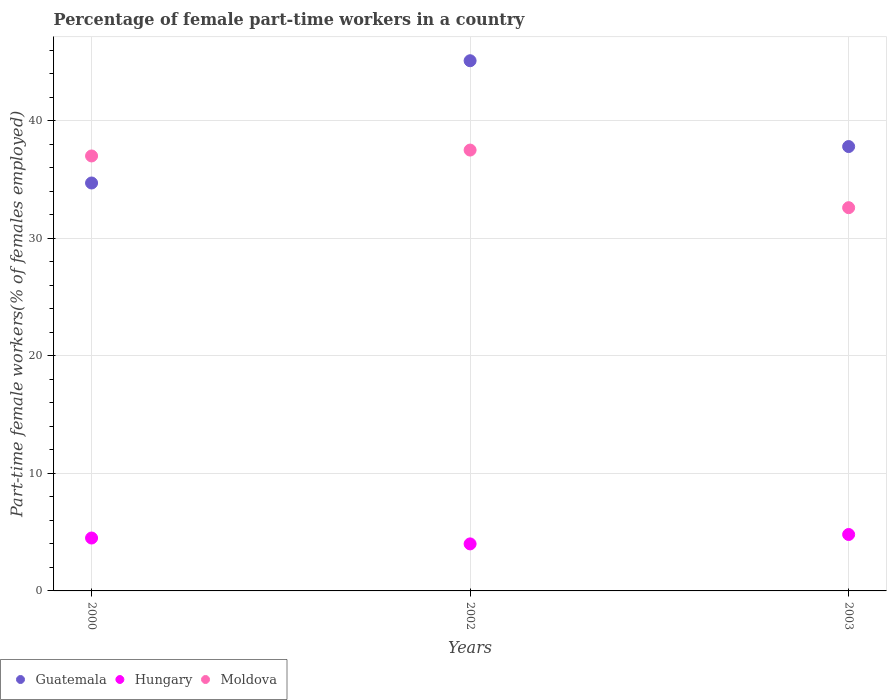Is the number of dotlines equal to the number of legend labels?
Provide a succinct answer. Yes. What is the percentage of female part-time workers in Moldova in 2003?
Provide a short and direct response. 32.6. Across all years, what is the maximum percentage of female part-time workers in Moldova?
Your answer should be very brief. 37.5. Across all years, what is the minimum percentage of female part-time workers in Moldova?
Give a very brief answer. 32.6. In which year was the percentage of female part-time workers in Hungary maximum?
Provide a succinct answer. 2003. In which year was the percentage of female part-time workers in Moldova minimum?
Make the answer very short. 2003. What is the total percentage of female part-time workers in Hungary in the graph?
Give a very brief answer. 13.3. What is the difference between the percentage of female part-time workers in Guatemala in 2002 and that in 2003?
Keep it short and to the point. 7.3. What is the difference between the percentage of female part-time workers in Moldova in 2003 and the percentage of female part-time workers in Hungary in 2000?
Ensure brevity in your answer.  28.1. What is the average percentage of female part-time workers in Guatemala per year?
Offer a terse response. 39.2. In the year 2000, what is the difference between the percentage of female part-time workers in Guatemala and percentage of female part-time workers in Hungary?
Keep it short and to the point. 30.2. In how many years, is the percentage of female part-time workers in Moldova greater than 26 %?
Make the answer very short. 3. What is the ratio of the percentage of female part-time workers in Guatemala in 2002 to that in 2003?
Provide a short and direct response. 1.19. Is the difference between the percentage of female part-time workers in Guatemala in 2000 and 2003 greater than the difference between the percentage of female part-time workers in Hungary in 2000 and 2003?
Your response must be concise. No. What is the difference between the highest and the lowest percentage of female part-time workers in Moldova?
Offer a terse response. 4.9. Is the sum of the percentage of female part-time workers in Guatemala in 2000 and 2002 greater than the maximum percentage of female part-time workers in Moldova across all years?
Keep it short and to the point. Yes. Is the percentage of female part-time workers in Moldova strictly less than the percentage of female part-time workers in Hungary over the years?
Provide a short and direct response. No. What is the difference between two consecutive major ticks on the Y-axis?
Your answer should be very brief. 10. Where does the legend appear in the graph?
Provide a short and direct response. Bottom left. How many legend labels are there?
Your answer should be compact. 3. What is the title of the graph?
Make the answer very short. Percentage of female part-time workers in a country. Does "Bhutan" appear as one of the legend labels in the graph?
Provide a short and direct response. No. What is the label or title of the X-axis?
Keep it short and to the point. Years. What is the label or title of the Y-axis?
Provide a succinct answer. Part-time female workers(% of females employed). What is the Part-time female workers(% of females employed) in Guatemala in 2000?
Give a very brief answer. 34.7. What is the Part-time female workers(% of females employed) of Moldova in 2000?
Provide a succinct answer. 37. What is the Part-time female workers(% of females employed) of Guatemala in 2002?
Make the answer very short. 45.1. What is the Part-time female workers(% of females employed) in Moldova in 2002?
Your answer should be very brief. 37.5. What is the Part-time female workers(% of females employed) in Guatemala in 2003?
Keep it short and to the point. 37.8. What is the Part-time female workers(% of females employed) in Hungary in 2003?
Make the answer very short. 4.8. What is the Part-time female workers(% of females employed) in Moldova in 2003?
Keep it short and to the point. 32.6. Across all years, what is the maximum Part-time female workers(% of females employed) of Guatemala?
Your answer should be very brief. 45.1. Across all years, what is the maximum Part-time female workers(% of females employed) of Hungary?
Ensure brevity in your answer.  4.8. Across all years, what is the maximum Part-time female workers(% of females employed) in Moldova?
Your response must be concise. 37.5. Across all years, what is the minimum Part-time female workers(% of females employed) in Guatemala?
Give a very brief answer. 34.7. Across all years, what is the minimum Part-time female workers(% of females employed) in Moldova?
Your answer should be very brief. 32.6. What is the total Part-time female workers(% of females employed) in Guatemala in the graph?
Give a very brief answer. 117.6. What is the total Part-time female workers(% of females employed) of Moldova in the graph?
Provide a short and direct response. 107.1. What is the difference between the Part-time female workers(% of females employed) of Moldova in 2000 and that in 2002?
Make the answer very short. -0.5. What is the difference between the Part-time female workers(% of females employed) of Guatemala in 2000 and that in 2003?
Your answer should be compact. -3.1. What is the difference between the Part-time female workers(% of females employed) in Moldova in 2000 and that in 2003?
Your answer should be compact. 4.4. What is the difference between the Part-time female workers(% of females employed) of Guatemala in 2002 and that in 2003?
Provide a succinct answer. 7.3. What is the difference between the Part-time female workers(% of females employed) in Hungary in 2002 and that in 2003?
Give a very brief answer. -0.8. What is the difference between the Part-time female workers(% of females employed) of Moldova in 2002 and that in 2003?
Keep it short and to the point. 4.9. What is the difference between the Part-time female workers(% of females employed) of Guatemala in 2000 and the Part-time female workers(% of females employed) of Hungary in 2002?
Offer a very short reply. 30.7. What is the difference between the Part-time female workers(% of females employed) in Hungary in 2000 and the Part-time female workers(% of females employed) in Moldova in 2002?
Offer a very short reply. -33. What is the difference between the Part-time female workers(% of females employed) of Guatemala in 2000 and the Part-time female workers(% of females employed) of Hungary in 2003?
Make the answer very short. 29.9. What is the difference between the Part-time female workers(% of females employed) of Guatemala in 2000 and the Part-time female workers(% of females employed) of Moldova in 2003?
Your answer should be very brief. 2.1. What is the difference between the Part-time female workers(% of females employed) of Hungary in 2000 and the Part-time female workers(% of females employed) of Moldova in 2003?
Offer a terse response. -28.1. What is the difference between the Part-time female workers(% of females employed) in Guatemala in 2002 and the Part-time female workers(% of females employed) in Hungary in 2003?
Offer a very short reply. 40.3. What is the difference between the Part-time female workers(% of females employed) of Guatemala in 2002 and the Part-time female workers(% of females employed) of Moldova in 2003?
Make the answer very short. 12.5. What is the difference between the Part-time female workers(% of females employed) of Hungary in 2002 and the Part-time female workers(% of females employed) of Moldova in 2003?
Give a very brief answer. -28.6. What is the average Part-time female workers(% of females employed) of Guatemala per year?
Give a very brief answer. 39.2. What is the average Part-time female workers(% of females employed) in Hungary per year?
Make the answer very short. 4.43. What is the average Part-time female workers(% of females employed) of Moldova per year?
Offer a very short reply. 35.7. In the year 2000, what is the difference between the Part-time female workers(% of females employed) of Guatemala and Part-time female workers(% of females employed) of Hungary?
Ensure brevity in your answer.  30.2. In the year 2000, what is the difference between the Part-time female workers(% of females employed) of Hungary and Part-time female workers(% of females employed) of Moldova?
Provide a succinct answer. -32.5. In the year 2002, what is the difference between the Part-time female workers(% of females employed) in Guatemala and Part-time female workers(% of females employed) in Hungary?
Your response must be concise. 41.1. In the year 2002, what is the difference between the Part-time female workers(% of females employed) in Hungary and Part-time female workers(% of females employed) in Moldova?
Provide a succinct answer. -33.5. In the year 2003, what is the difference between the Part-time female workers(% of females employed) of Guatemala and Part-time female workers(% of females employed) of Hungary?
Your response must be concise. 33. In the year 2003, what is the difference between the Part-time female workers(% of females employed) of Guatemala and Part-time female workers(% of females employed) of Moldova?
Give a very brief answer. 5.2. In the year 2003, what is the difference between the Part-time female workers(% of females employed) in Hungary and Part-time female workers(% of females employed) in Moldova?
Provide a short and direct response. -27.8. What is the ratio of the Part-time female workers(% of females employed) in Guatemala in 2000 to that in 2002?
Your answer should be compact. 0.77. What is the ratio of the Part-time female workers(% of females employed) in Hungary in 2000 to that in 2002?
Your response must be concise. 1.12. What is the ratio of the Part-time female workers(% of females employed) in Moldova in 2000 to that in 2002?
Your response must be concise. 0.99. What is the ratio of the Part-time female workers(% of females employed) in Guatemala in 2000 to that in 2003?
Keep it short and to the point. 0.92. What is the ratio of the Part-time female workers(% of females employed) of Moldova in 2000 to that in 2003?
Your answer should be very brief. 1.14. What is the ratio of the Part-time female workers(% of females employed) in Guatemala in 2002 to that in 2003?
Offer a terse response. 1.19. What is the ratio of the Part-time female workers(% of females employed) in Hungary in 2002 to that in 2003?
Keep it short and to the point. 0.83. What is the ratio of the Part-time female workers(% of females employed) in Moldova in 2002 to that in 2003?
Give a very brief answer. 1.15. What is the difference between the highest and the second highest Part-time female workers(% of females employed) in Guatemala?
Offer a very short reply. 7.3. What is the difference between the highest and the second highest Part-time female workers(% of females employed) of Hungary?
Your response must be concise. 0.3. What is the difference between the highest and the second highest Part-time female workers(% of females employed) in Moldova?
Give a very brief answer. 0.5. What is the difference between the highest and the lowest Part-time female workers(% of females employed) in Guatemala?
Offer a very short reply. 10.4. What is the difference between the highest and the lowest Part-time female workers(% of females employed) in Hungary?
Give a very brief answer. 0.8. 